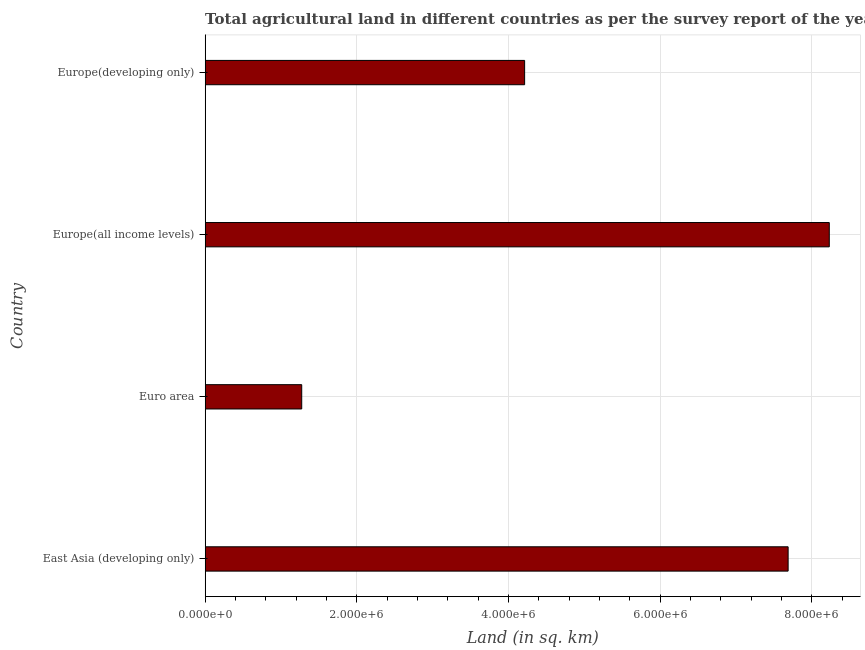What is the title of the graph?
Make the answer very short. Total agricultural land in different countries as per the survey report of the year 2000. What is the label or title of the X-axis?
Provide a succinct answer. Land (in sq. km). What is the label or title of the Y-axis?
Ensure brevity in your answer.  Country. What is the agricultural land in Europe(all income levels)?
Offer a very short reply. 8.23e+06. Across all countries, what is the maximum agricultural land?
Your answer should be very brief. 8.23e+06. Across all countries, what is the minimum agricultural land?
Provide a succinct answer. 1.27e+06. In which country was the agricultural land maximum?
Make the answer very short. Europe(all income levels). In which country was the agricultural land minimum?
Make the answer very short. Euro area. What is the sum of the agricultural land?
Make the answer very short. 2.14e+07. What is the difference between the agricultural land in East Asia (developing only) and Euro area?
Your answer should be very brief. 6.41e+06. What is the average agricultural land per country?
Your answer should be compact. 5.35e+06. What is the median agricultural land?
Your answer should be very brief. 5.95e+06. In how many countries, is the agricultural land greater than 7600000 sq. km?
Your answer should be very brief. 2. What is the ratio of the agricultural land in East Asia (developing only) to that in Europe(developing only)?
Ensure brevity in your answer.  1.82. Is the agricultural land in Euro area less than that in Europe(all income levels)?
Your answer should be very brief. Yes. What is the difference between the highest and the second highest agricultural land?
Offer a very short reply. 5.43e+05. Is the sum of the agricultural land in Euro area and Europe(all income levels) greater than the maximum agricultural land across all countries?
Your answer should be compact. Yes. What is the difference between the highest and the lowest agricultural land?
Offer a very short reply. 6.96e+06. How many countries are there in the graph?
Your answer should be very brief. 4. Are the values on the major ticks of X-axis written in scientific E-notation?
Your answer should be very brief. Yes. What is the Land (in sq. km) in East Asia (developing only)?
Provide a short and direct response. 7.69e+06. What is the Land (in sq. km) of Euro area?
Offer a terse response. 1.27e+06. What is the Land (in sq. km) in Europe(all income levels)?
Give a very brief answer. 8.23e+06. What is the Land (in sq. km) in Europe(developing only)?
Your response must be concise. 4.21e+06. What is the difference between the Land (in sq. km) in East Asia (developing only) and Euro area?
Ensure brevity in your answer.  6.41e+06. What is the difference between the Land (in sq. km) in East Asia (developing only) and Europe(all income levels)?
Offer a very short reply. -5.43e+05. What is the difference between the Land (in sq. km) in East Asia (developing only) and Europe(developing only)?
Provide a succinct answer. 3.47e+06. What is the difference between the Land (in sq. km) in Euro area and Europe(all income levels)?
Your response must be concise. -6.96e+06. What is the difference between the Land (in sq. km) in Euro area and Europe(developing only)?
Offer a very short reply. -2.94e+06. What is the difference between the Land (in sq. km) in Europe(all income levels) and Europe(developing only)?
Keep it short and to the point. 4.02e+06. What is the ratio of the Land (in sq. km) in East Asia (developing only) to that in Euro area?
Make the answer very short. 6.04. What is the ratio of the Land (in sq. km) in East Asia (developing only) to that in Europe(all income levels)?
Your answer should be compact. 0.93. What is the ratio of the Land (in sq. km) in East Asia (developing only) to that in Europe(developing only)?
Your response must be concise. 1.82. What is the ratio of the Land (in sq. km) in Euro area to that in Europe(all income levels)?
Keep it short and to the point. 0.15. What is the ratio of the Land (in sq. km) in Euro area to that in Europe(developing only)?
Provide a short and direct response. 0.3. What is the ratio of the Land (in sq. km) in Europe(all income levels) to that in Europe(developing only)?
Give a very brief answer. 1.95. 